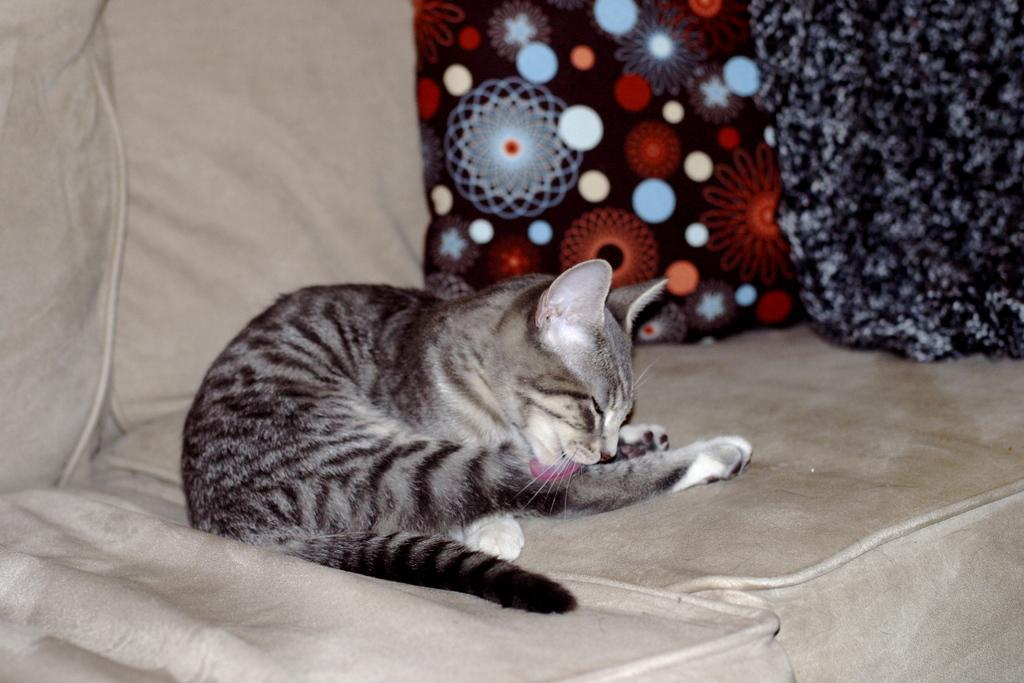What type of animal is in the image? There is a cat in the image. What piece of furniture is in the image? There is a couch in the image. What additional items are on the couch? There are pillows in the image. What type of fowl can be seen flying over the couch in the image? There is no fowl present in the image; it only features a cat, a couch, and pillows. 